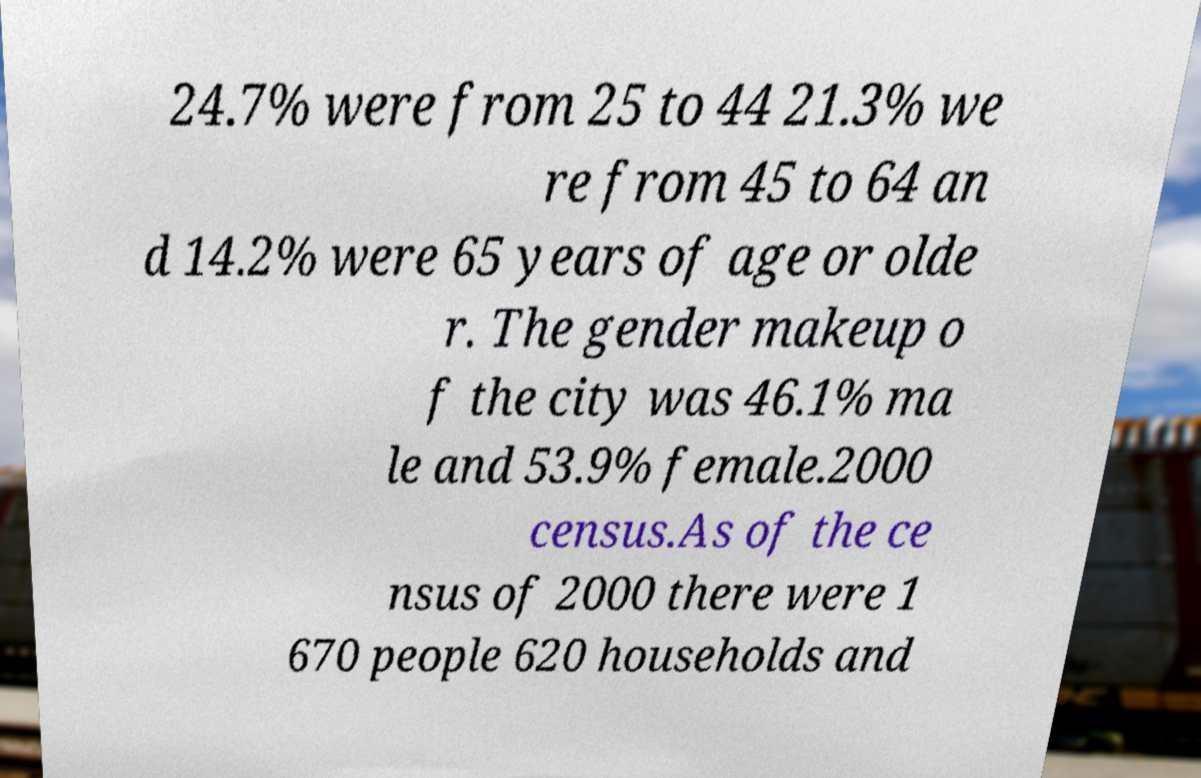Please read and relay the text visible in this image. What does it say? 24.7% were from 25 to 44 21.3% we re from 45 to 64 an d 14.2% were 65 years of age or olde r. The gender makeup o f the city was 46.1% ma le and 53.9% female.2000 census.As of the ce nsus of 2000 there were 1 670 people 620 households and 